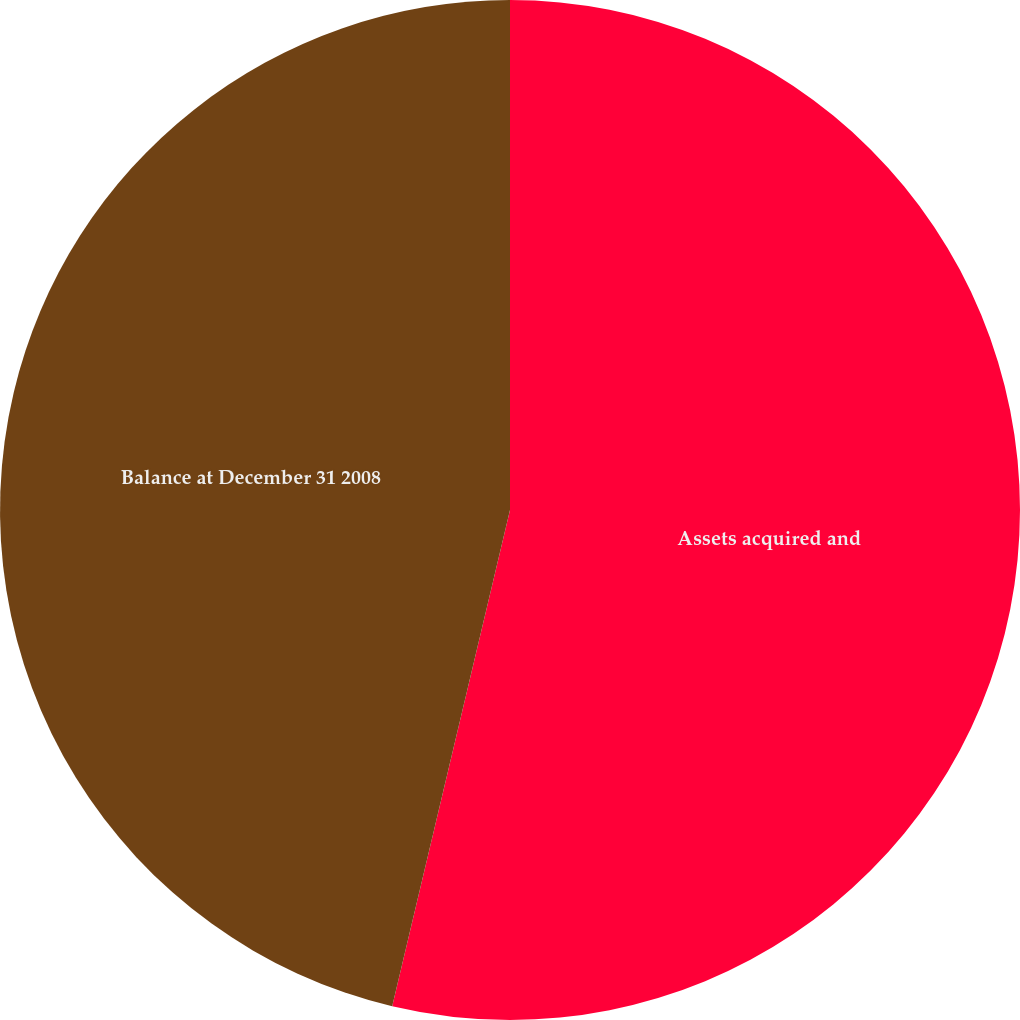<chart> <loc_0><loc_0><loc_500><loc_500><pie_chart><fcel>Assets acquired and<fcel>Balance at December 31 2008<nl><fcel>53.71%<fcel>46.29%<nl></chart> 